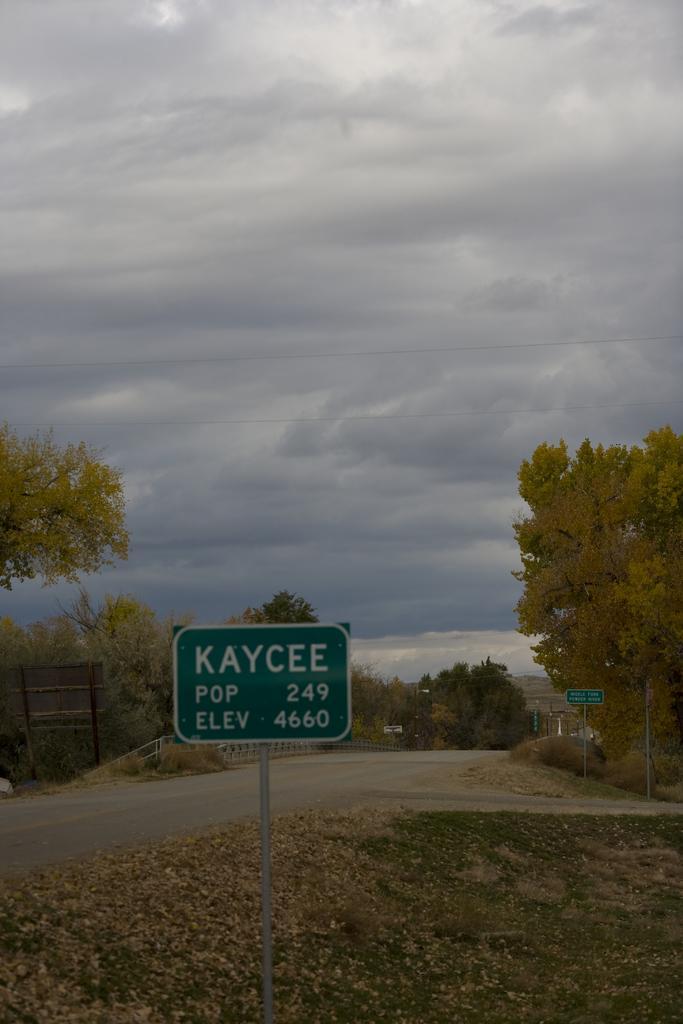Please provide a concise description of this image. In this image in the front there is a board with some text written on it and there are dry leaves on the grass and in the background there are trees and the sky is cloudy and there are boards with some text written on it. 